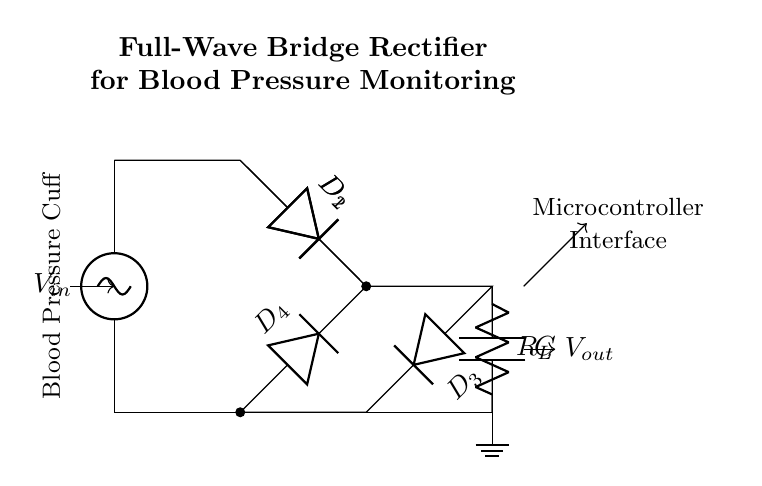What type of rectifier is shown in the diagram? The circuit diagram depicts a full-wave bridge rectifier, which is indicated by the arrangement of four diodes forming a bridge configuration to convert AC input to DC output.
Answer: full-wave bridge rectifier How many diodes are present in the circuit? The circuit contains four diodes, labeled D1, D2, D3, and D4, which are part of the bridge configuration necessary for full-wave rectification.
Answer: four What is the purpose of the capacitor in this circuit? The capacitor smooths out the output voltage by filtering the rectified waveform, reducing voltage ripple and providing a steadier voltage to the load.
Answer: to smooth the output voltage What component is labeled 'R_L' in the circuit? The labeled component 'R_L' represents the load resistor, which is connected in series with the output to draw current and allows for the measurement of voltage across it.
Answer: load resistor What is the relationship between the input voltage and output voltage in a full-wave bridge rectifier? The output voltage is approximately equal to the input voltage minus the forward voltage drops across two diodes in the bridge during conduction, ideally providing higher output than a half-wave rectifier.
Answer: V_out ≈ V_in - 2*V_d What additional component connects the output to a microcontroller interface? The interface to a microcontroller is connected from the output voltage node, allowing for processing or display of the blood pressure measurement derived from the rectified signal.
Answer: microcontroller Which component is responsible for directing current only in one direction? The diodes (D1, D2, D3, D4) function to ensure that current only flows in one direction during both halves of the AC waveform, crucial for the rectification process.
Answer: diodes 